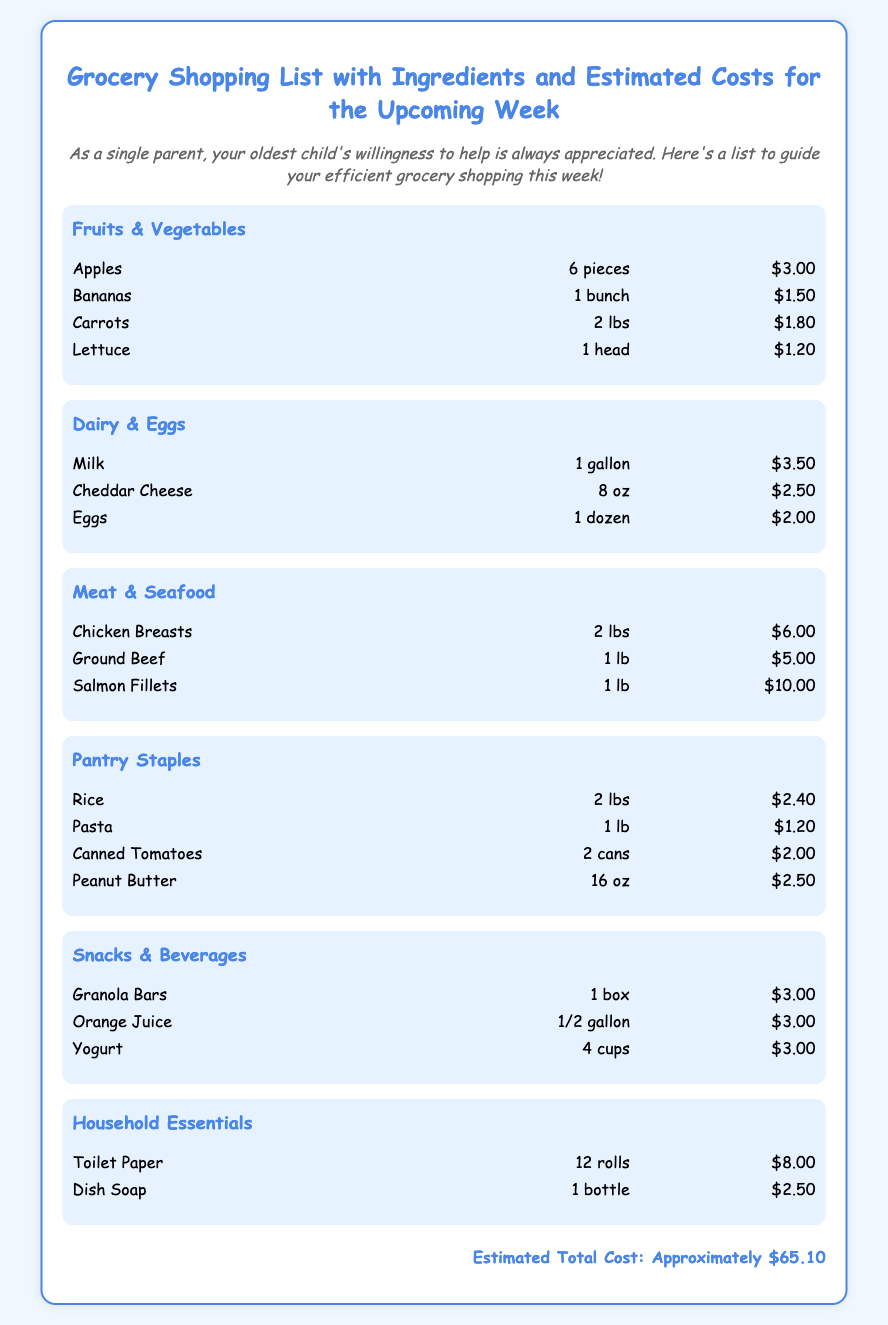What is the estimated total cost? The total cost is summarized at the bottom of the document, which states approximately $65.10.
Answer: Approximately $65.10 How many eggs are listed? The document specifies the quantity of eggs available in the Dairy & Eggs category, which is one dozen.
Answer: 1 dozen What type of cheese is included in the list? The item listed as cheese in the Dairy & Eggs category is Cheddar Cheese.
Answer: Cheddar Cheese How many fruits and vegetables items are on the list? The fruits and vegetables category has a total of four distinct items listed.
Answer: 4 items What is the cost of Chicken Breasts? The document provides the price for the Chicken Breasts under the Meat & Seafood category, which is $6.00.
Answer: $6.00 Which household essential item costs the most? The highest cost item in the Household Essentials category is Toilet Paper priced at $8.00.
Answer: Toilet Paper How many types of snacks are included in the list? There are three distinct snack items mentioned in the Snacks & Beverages category.
Answer: 3 types What food category contains canned items? The document lists Canned Tomatoes as part of the Pantry Staples category.
Answer: Pantry Staples What is the quantity of Rice listed? The Rice item in the Pantry Staples category specifies a total of 2 lbs.
Answer: 2 lbs 